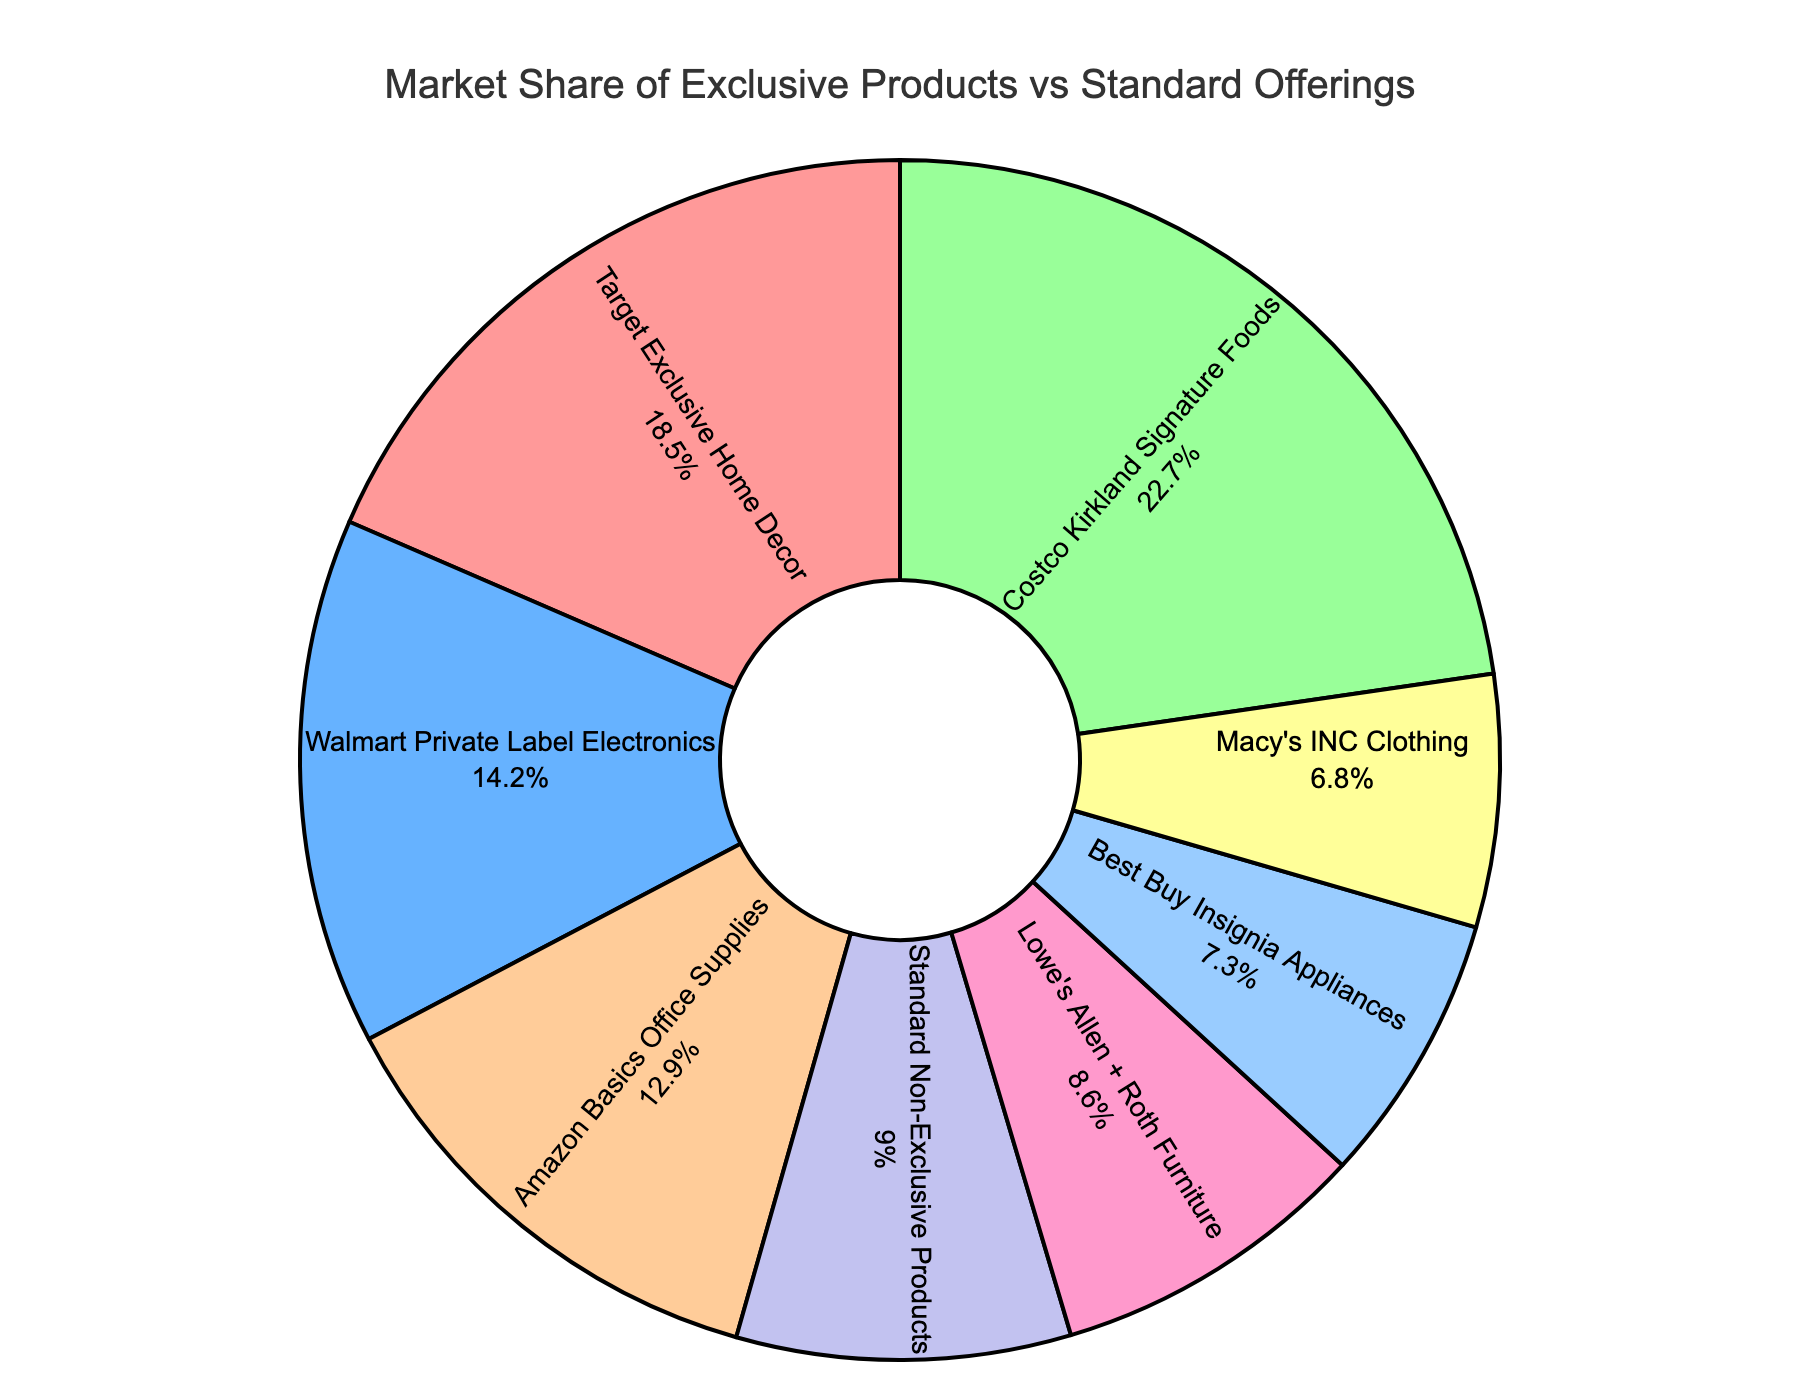What percentage of the market share does the Costco Kirkland Signature Foods category hold? The figure shows that the market share of Costco Kirkland Signature Foods is labeled as 22.7% in the pie chart.
Answer: 22.7% Which exclusive product category has a higher market share: Amazon Basics Office Supplies or Walmart Private Label Electronics? By looking at the respective market share percentages in the pie chart, Amazon Basics Office Supplies holds 12.9%, while Walmart Private Label Electronics holds 14.2%. Therefore, Walmart Private Label Electronics has a higher market share.
Answer: Walmart Private Label Electronics What is the total market share for all exclusive product categories combined? We need to sum the market share percentages of all exclusive product categories: Target Exclusive Home Decor (18.5%), Walmart Private Label Electronics (14.2%), Costco Kirkland Signature Foods (22.7%), Amazon Basics Office Supplies (12.9%), Lowe's Allen + Roth Furniture (8.6%), Best Buy Insignia Appliances (7.3%), and Macy's INC Clothing (6.8%). The total is 18.5 + 14.2 + 22.7 + 12.9 + 8.6 + 7.3 + 6.8 = 91%.
Answer: 91% How does the market share of Target Exclusive Home Decor compare to the market share of Standard Non-Exclusive Products? Target Exclusive Home Decor has a market share of 18.5%, while Standard Non-Exclusive Products have a market share of 9.0%. Therefore, Target Exclusive Home Decor has a higher market share.
Answer: Target Exclusive Home Decor Which product category holds the smallest market share? The figure shows that Best Buy Insignia Appliances has a market share of 7.3%, which is the smallest compared to other categories.
Answer: Best Buy Insignia Appliances What is the difference in market share between Costco Kirkland Signature Foods and Lowe's Allen + Roth Furniture? The market share of Costco Kirkland Signature Foods is 22.7%, and Lowe's Allen + Roth Furniture is 8.6%. The difference is 22.7% - 8.6% = 14.1%.
Answer: 14.1% Which product categories combined would yield a market share higher than 30%? We need to find combinations whose sum exceeds 30%. For instance, Walmart Private Label Electronics (14.2%) and Amazon Basics Office Supplies (12.9%) together give 27.1%, which is less than 30%. However, Target Exclusive Home Decor (18.5%) and Amazon Basics Office Supplies (12.9%) together give 31.4%, which is higher than 30%. Various other combinations with Costco Kirkland Signature Foods (22.7%) will also work.
Answer: Target Exclusive Home Decor and Amazon Basics Office Supplies 